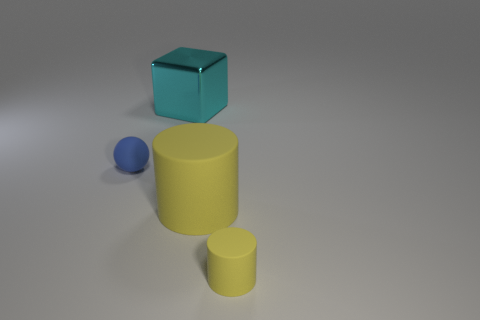Are the object behind the small sphere and the large cylinder made of the same material?
Your response must be concise. No. What material is the yellow cylinder that is left of the thing that is to the right of the yellow matte object that is on the left side of the tiny yellow cylinder?
Your answer should be compact. Rubber. What number of other things are the same shape as the tiny blue rubber object?
Offer a terse response. 0. What is the color of the small thing that is behind the tiny yellow rubber cylinder?
Keep it short and to the point. Blue. How many rubber things are right of the tiny matte thing that is to the left of the object behind the blue thing?
Your answer should be very brief. 2. There is a yellow matte object behind the small yellow cylinder; what number of cyan cubes are in front of it?
Keep it short and to the point. 0. There is a sphere; how many spheres are to the left of it?
Your response must be concise. 0. What number of other things are there of the same size as the ball?
Your response must be concise. 1. There is another rubber object that is the same shape as the large matte thing; what is its size?
Provide a succinct answer. Small. There is a big object in front of the tiny blue rubber sphere; what shape is it?
Your response must be concise. Cylinder. 